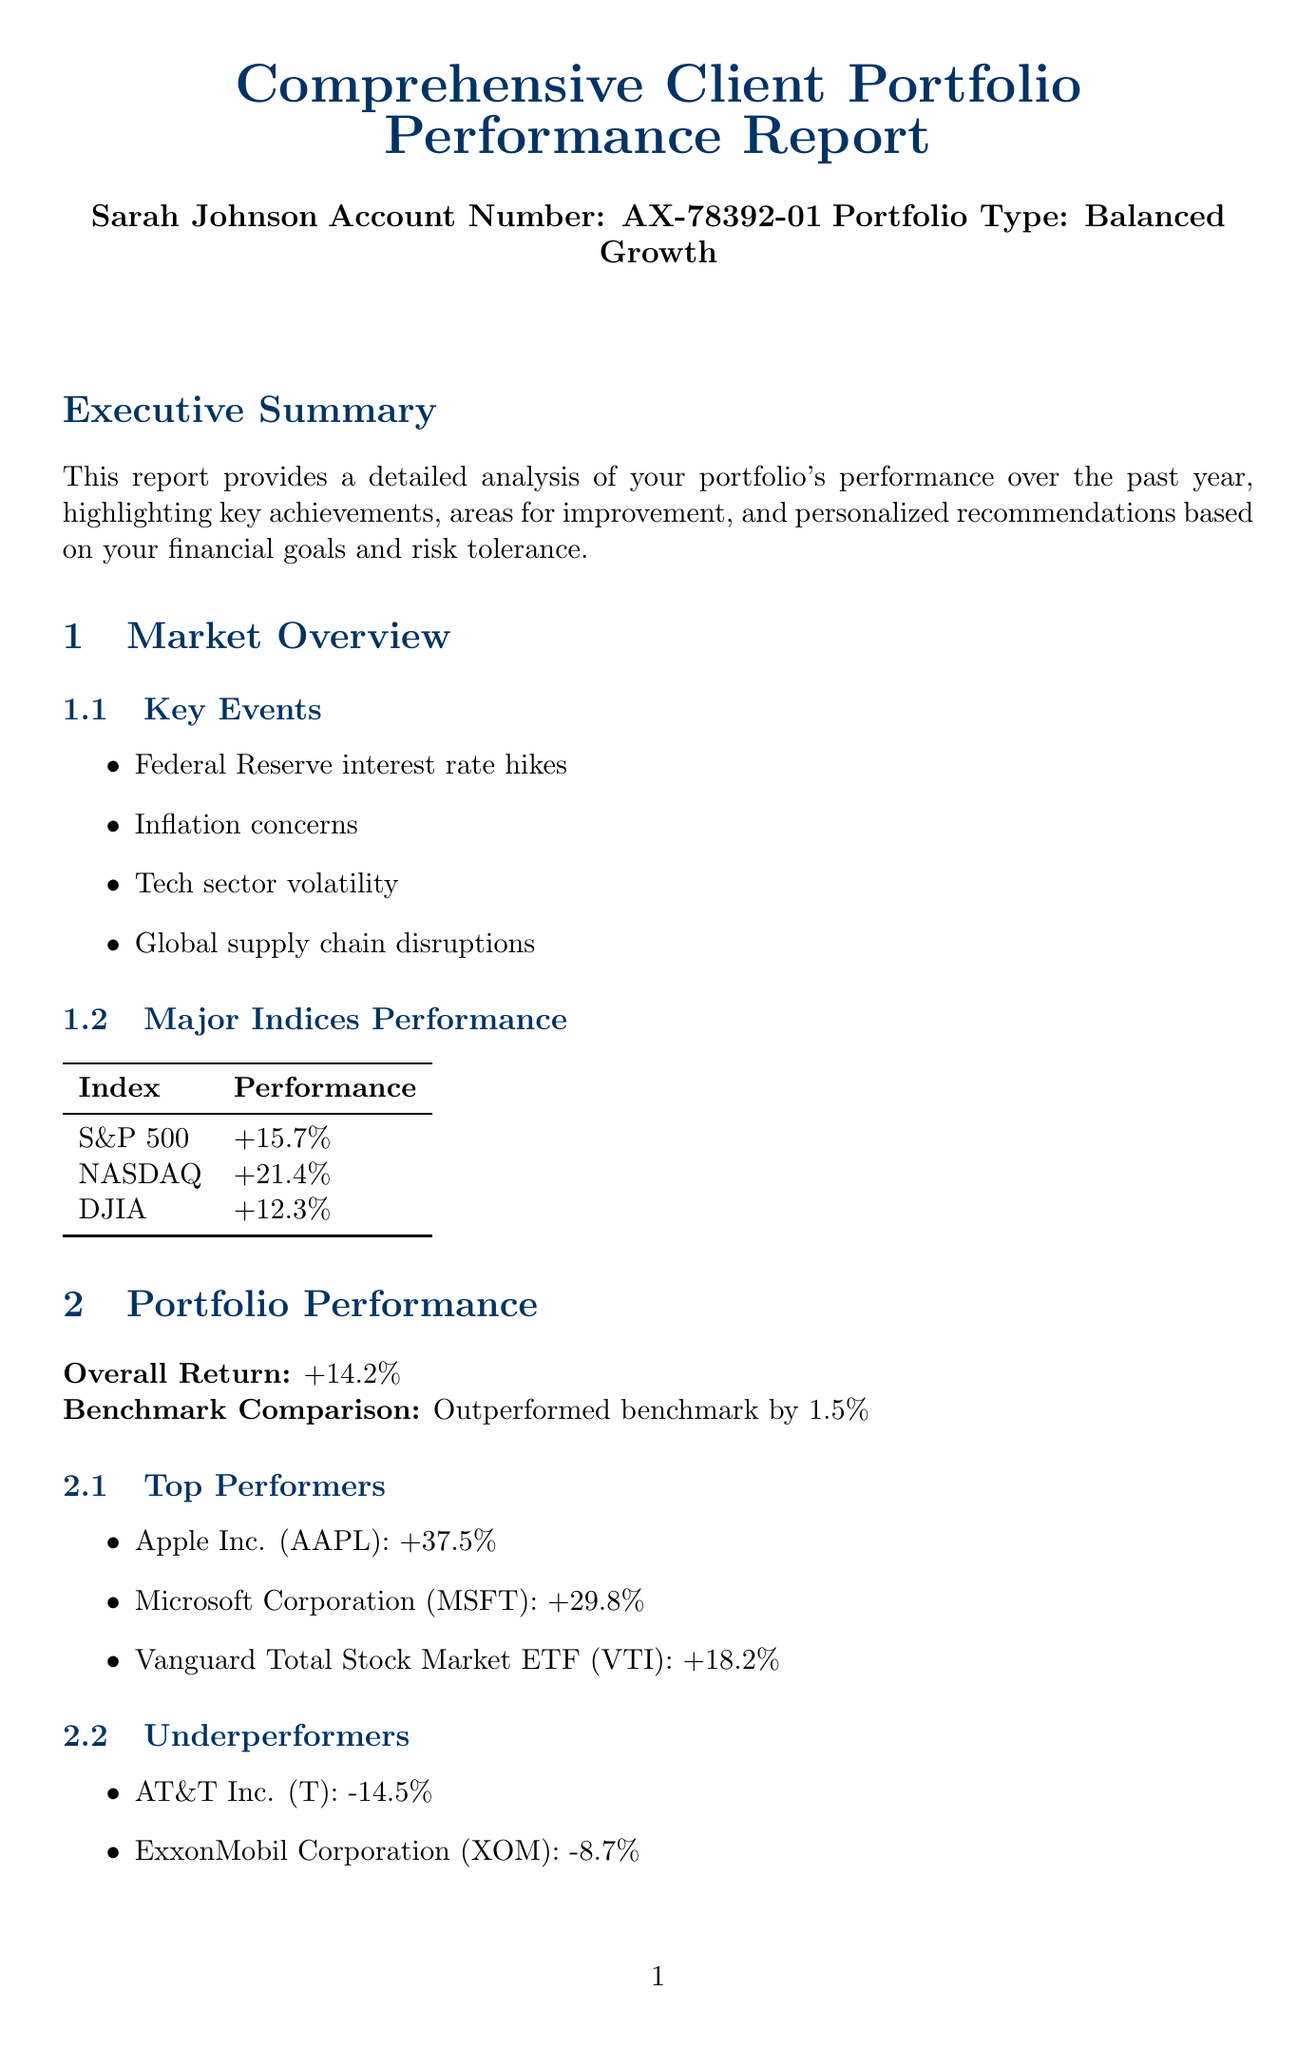What is the overall return of the portfolio? The overall return is stated in the portfolio performance section of the report.
Answer: +14.2% Who are the top three performers in the portfolio? The top performers are listed in the portfolio performance section, including their names.
Answer: Apple Inc. (AAPL), Microsoft Corporation (MSFT), Vanguard Total Stock Market ETF (VTI) What percentage of the portfolio is currently allocated to bonds? The current allocation for bonds is found in the asset allocation section.
Answer: 30% What is the recommended change for the cash allocation? The recommended changes for asset allocation are detailed in the asset allocation section.
Answer: -2% What rationale is provided for increasing exposure to emerging markets? The rationale for this recommendation is explained in the personalized recommendations section.
Answer: Diversify portfolio and capture growth potential in developing economies Which index had the highest performance over the year? The performance of major indices is summarized in the market overview section of the report.
Answer: NASDAQ What is the suggested action for rebalancing fixed income holdings? The suggested action is included in the personalized recommendations section of the report.
Answer: Shift 2% from long-term bonds to short-term bond funds like Vanguard Short-Term Bond ETF (BSV) When should the next consultation be scheduled? The next steps indicate when the consultation should occur.
Answer: To discuss the report in detail 